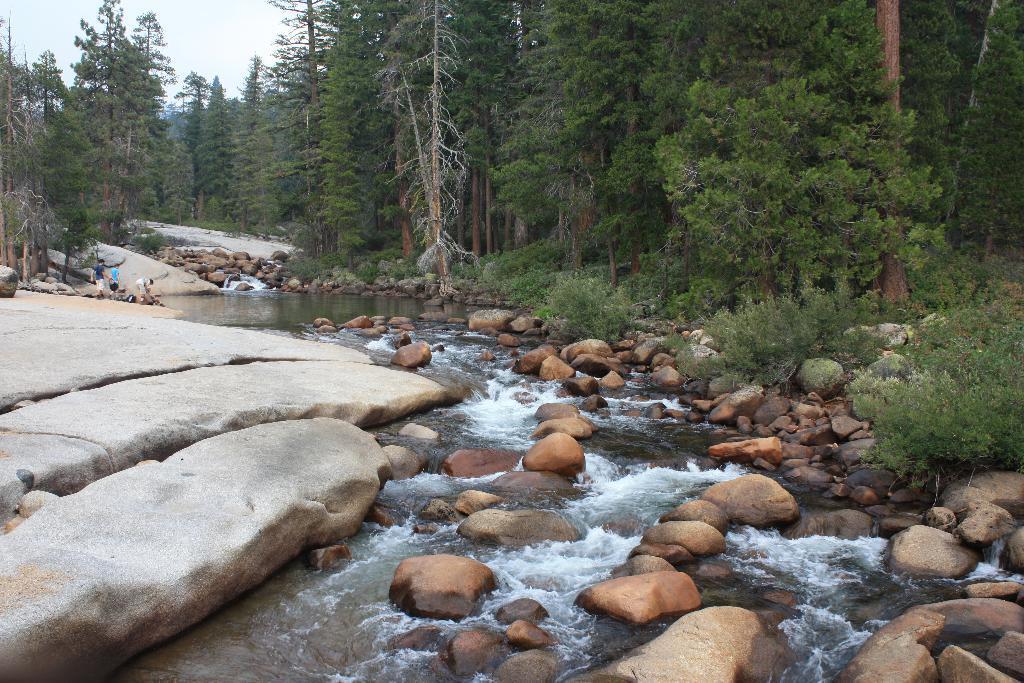Please provide a concise description of this image. In this picture we can see stones, plants, water, trees and some people on rocks and in the background we can see the sky. 